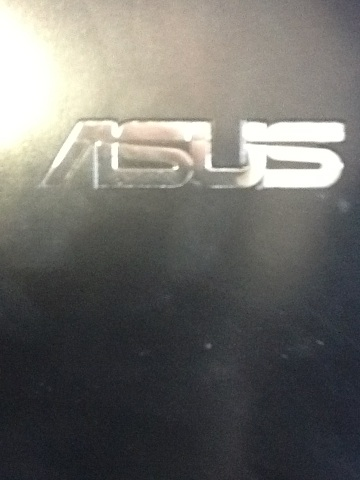Imagine this logo is part of a futuristic device. What kind of device could it be, and what features might it have? Imagine a futuristic Asus device called the 'Asus HoloPad.' This device is a hybrid between a tablet and a holographic projector. The HoloPad can project interactive 3D holograms for immersive gaming, virtual meetings, and even detailed architectural visualizations. It can be controlled through voice commands and gestures, and it uses advanced AI to provide personalized assistance and suggestions for various tasks. Additionally, it features a solar-charging capability, ensuring it never runs out of power while on the go. 